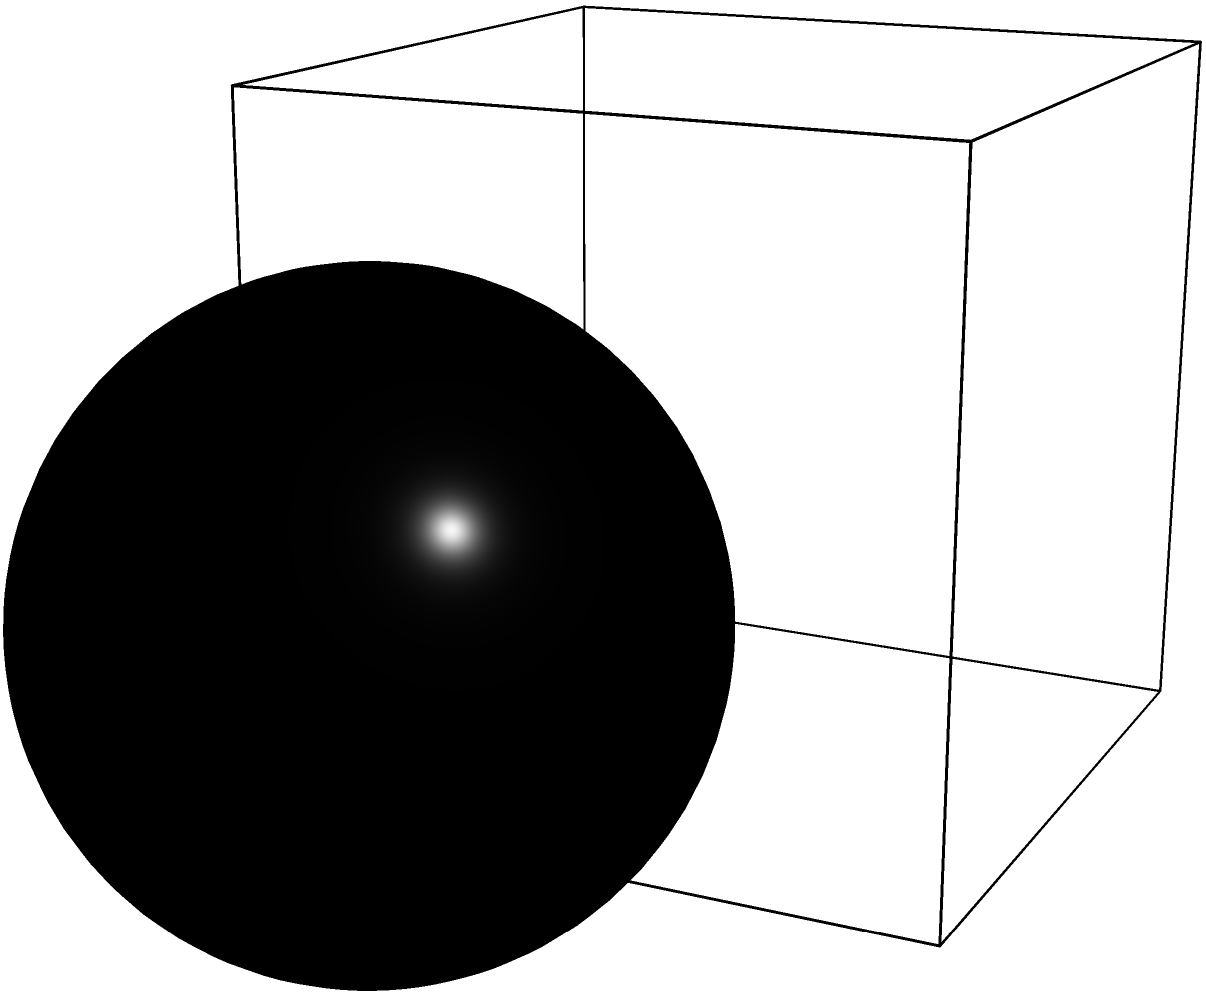A modernist sculpture consists of a cube (2m x 2m x 2m), a sphere (radius 0.8m), and a cylinder (radius 0.6m, height 2m). If one coat of paint covers 5 square meters, how many coats of paint are needed to fully cover the sculpture, rounded up to the nearest whole number? Let's calculate the surface area of each component:

1. Cube: 
   Surface area = $6 * side^2 = 6 * 2^2 = 24$ m²

2. Sphere:
   Surface area = $4\pi r^2 = 4\pi * 0.8^2 \approx 8.04$ m²

3. Cylinder:
   Surface area = $2\pi r^2 + 2\pi rh = 2\pi * 0.6^2 + 2\pi * 0.6 * 2 \approx 9.05$ m²

Total surface area = $24 + 8.04 + 9.05 = 41.09$ m²

One coat covers 5 m², so we need:
$41.09 / 5 \approx 8.218$ coats

Rounding up to the nearest whole number: 9 coats
Answer: 9 coats 